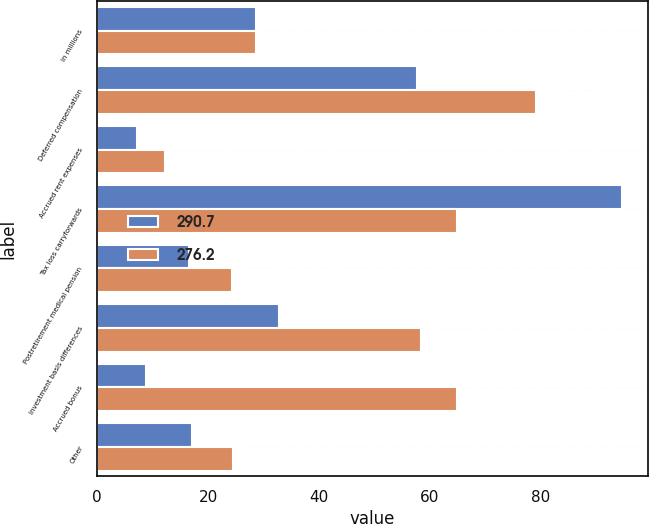Convert chart to OTSL. <chart><loc_0><loc_0><loc_500><loc_500><stacked_bar_chart><ecel><fcel>in millions<fcel>Deferred compensation<fcel>Accrued rent expenses<fcel>Tax loss carryforwards<fcel>Postretirement medical pension<fcel>Investment basis differences<fcel>Accrued bonus<fcel>Other<nl><fcel>290.7<fcel>28.65<fcel>57.6<fcel>7.2<fcel>94.6<fcel>16.6<fcel>32.8<fcel>8.8<fcel>17.2<nl><fcel>276.2<fcel>28.65<fcel>79.1<fcel>12.3<fcel>64.8<fcel>24.4<fcel>58.3<fcel>64.8<fcel>24.5<nl></chart> 